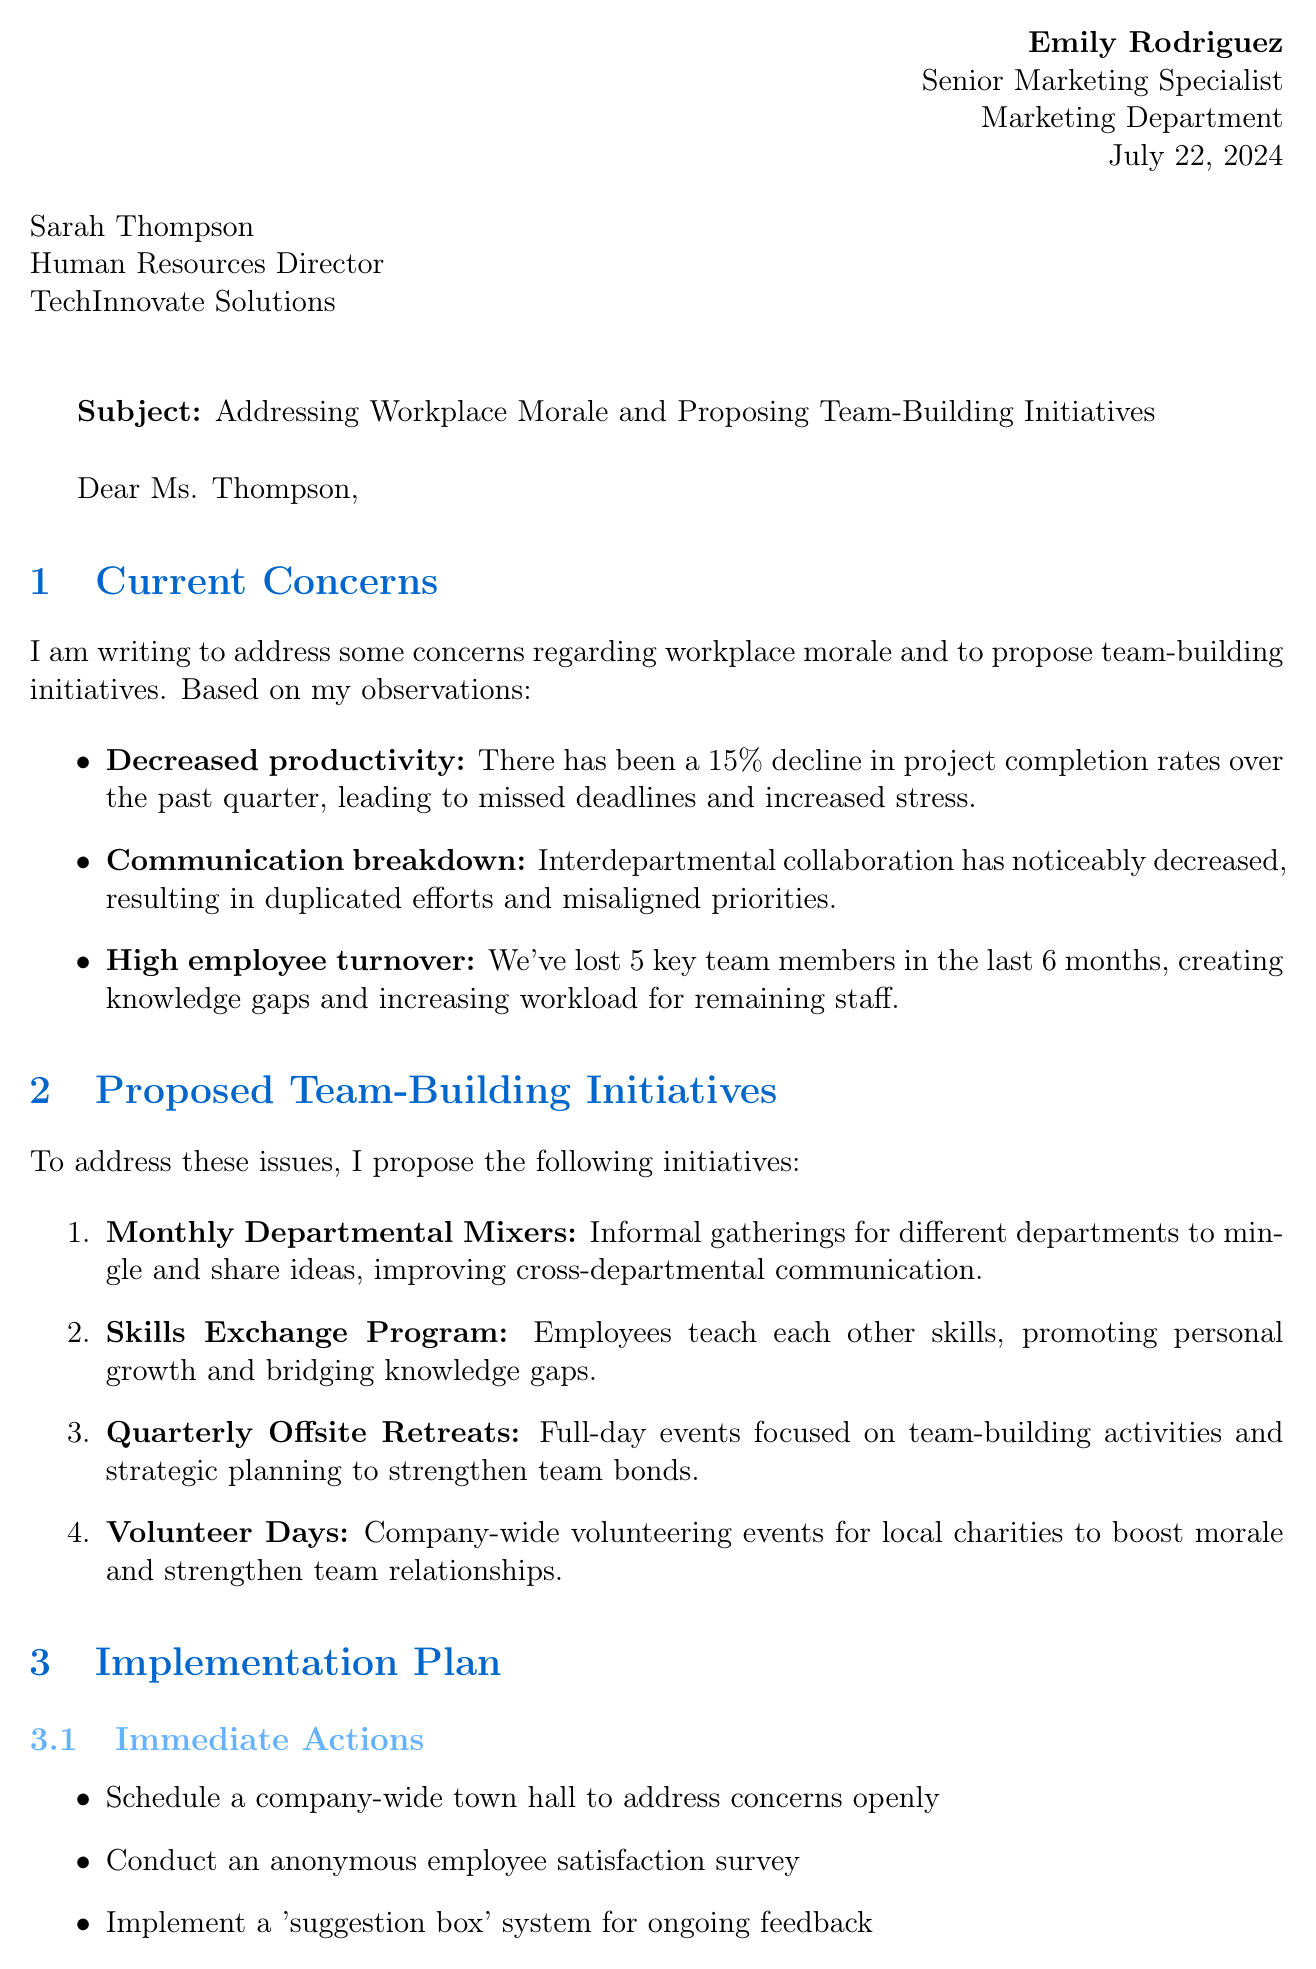What is the sender's name? The sender's name is provided in the header of the letter as Emily Rodriguez.
Answer: Emily Rodriguez What percentage decline in project completion rates is observed? The letter states that there has been a 15% decline in project completion rates over the past quarter.
Answer: 15% How many key team members were lost in the last 6 months? The letter mentions that 5 key team members have been lost in the last 6 months.
Answer: 5 What initiative is planned to launch within 30 days? The letter outlines the launch of the Monthly Departmental Mixers as an initiative to be launched within 30 days.
Answer: Monthly Departmental Mixers What is the benefit of the Skills Exchange Program? The letter states that the benefit of the Skills Exchange Program is to promote personal growth and help bridge knowledge gaps within the company.
Answer: Promotes personal growth What is the expected outcome mentioned in the closing remarks? The expected outcome is to significantly improve workplace morale and productivity at TechInnovate Solutions by addressing concerns and implementing initiatives.
Answer: Improve workplace morale and productivity Who is the recipient of the letter? The recipient of the letter, as mentioned in the header, is Sarah Thompson.
Answer: Sarah Thompson What is one immediate action suggested in the implementation plan? Among the immediate actions suggested is to schedule a company-wide town hall to address concerns openly.
Answer: Schedule a company-wide town hall 